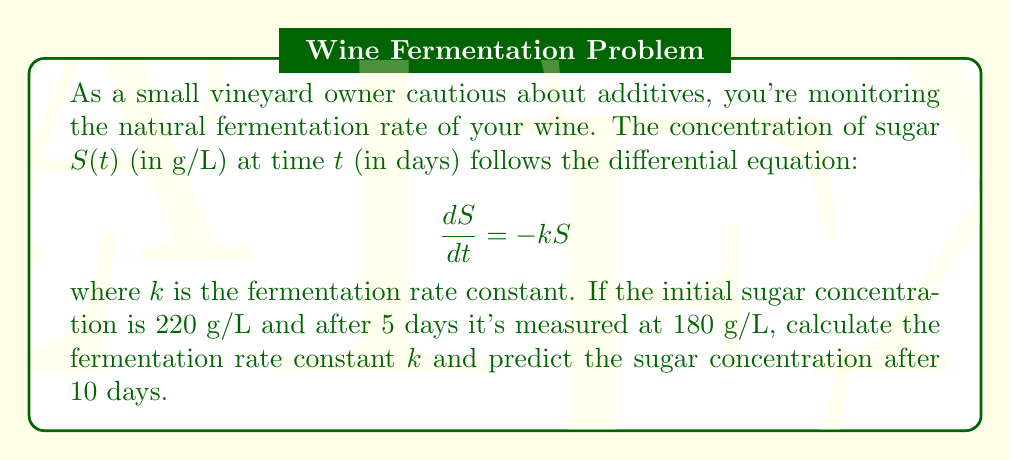Provide a solution to this math problem. To solve this problem, we'll follow these steps:

1) The given differential equation is a first-order linear equation with a solution of the form:

   $$S(t) = S_0e^{-kt}$$

   where $S_0$ is the initial sugar concentration.

2) We're given two points:
   At $t=0$, $S=220$ g/L
   At $t=5$, $S=180$ g/L

3) Let's use these to find $k$:

   $$180 = 220e^{-5k}$$

4) Taking natural logarithm of both sides:

   $$\ln(180) = \ln(220) - 5k$$

5) Solving for $k$:

   $$k = \frac{\ln(220) - \ln(180)}{5} = \frac{\ln(220/180)}{5} \approx 0.0401\text{ day}^{-1}$$

6) Now that we have $k$, we can predict the sugar concentration after 10 days:

   $$S(10) = 220e^{-0.0401 \times 10} \approx 147.3\text{ g/L}$$

This approach allows us to model the fermentation process without using additives, aligning with the vineyard owner's cautious approach to winemaking.
Answer: The fermentation rate constant $k \approx 0.0401\text{ day}^{-1}$, and the predicted sugar concentration after 10 days is approximately 147.3 g/L. 